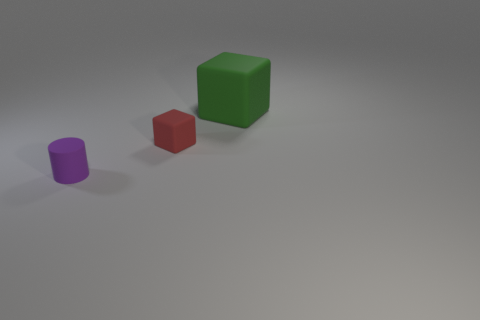Is there anything else that has the same size as the green object?
Provide a succinct answer. No. What number of other things are there of the same color as the small cylinder?
Your response must be concise. 0. How many objects are tiny things that are to the right of the small purple rubber cylinder or tiny matte things that are in front of the small red thing?
Your answer should be very brief. 2. How big is the block that is to the right of the cube to the left of the big green rubber object?
Make the answer very short. Large. What is the size of the green matte block?
Make the answer very short. Large. Are there any tiny red spheres?
Offer a very short reply. No. Is the object in front of the tiny red object made of the same material as the green thing?
Make the answer very short. Yes. Are there fewer small purple matte objects than blocks?
Offer a very short reply. Yes. There is a tiny object that is the same material as the purple cylinder; what color is it?
Offer a very short reply. Red. Do the green object and the purple object have the same size?
Your response must be concise. No. 